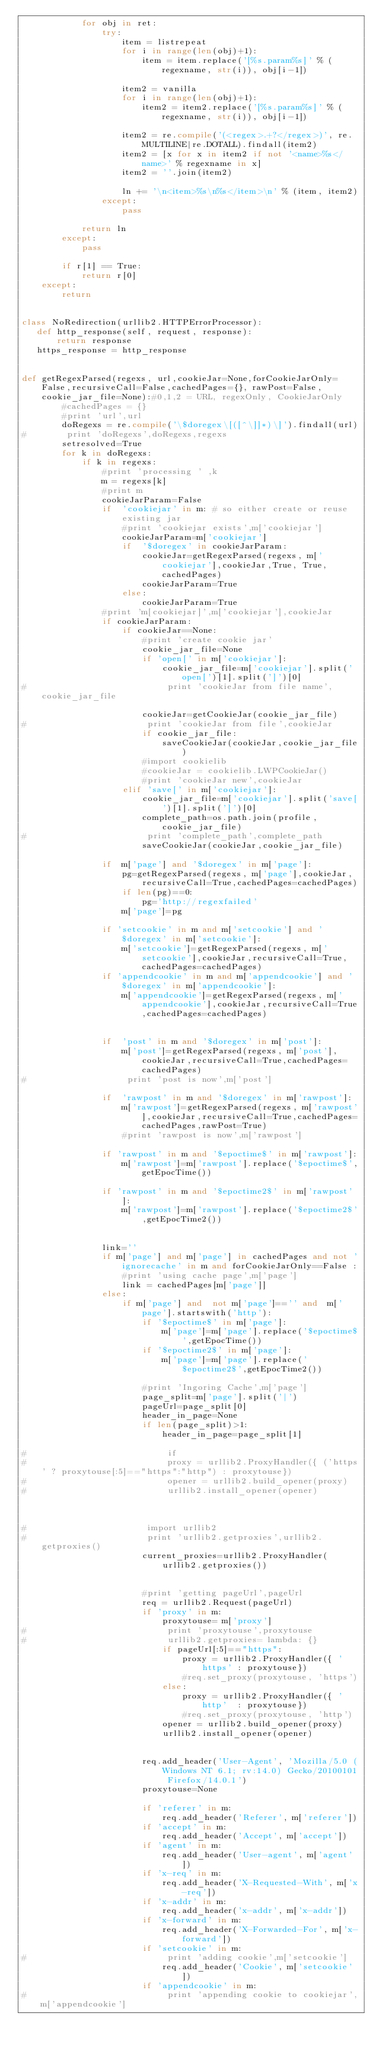<code> <loc_0><loc_0><loc_500><loc_500><_Python_>            for obj in ret:
                try:
                    item = listrepeat
                    for i in range(len(obj)+1):
                        item = item.replace('[%s.param%s]' % (regexname, str(i)), obj[i-1])

                    item2 = vanilla
                    for i in range(len(obj)+1):
                        item2 = item2.replace('[%s.param%s]' % (regexname, str(i)), obj[i-1])

                    item2 = re.compile('(<regex>.+?</regex>)', re.MULTILINE|re.DOTALL).findall(item2)
                    item2 = [x for x in item2 if not '<name>%s</name>' % regexname in x]
                    item2 = ''.join(item2)

                    ln += '\n<item>%s\n%s</item>\n' % (item, item2)
                except:
                    pass

            return ln
        except:
            pass

        if r[1] == True:
            return r[0]
    except:
        return


class NoRedirection(urllib2.HTTPErrorProcessor):
   def http_response(self, request, response):
       return response
   https_response = http_response


def getRegexParsed(regexs, url,cookieJar=None,forCookieJarOnly=False,recursiveCall=False,cachedPages={}, rawPost=False, cookie_jar_file=None):#0,1,2 = URL, regexOnly, CookieJarOnly
        #cachedPages = {}
        #print 'url',url
        doRegexs = re.compile('\$doregex\[([^\]]*)\]').findall(url)
#        print 'doRegexs',doRegexs,regexs
        setresolved=True
        for k in doRegexs:
            if k in regexs:
                #print 'processing ' ,k
                m = regexs[k]
                #print m
                cookieJarParam=False
                if  'cookiejar' in m: # so either create or reuse existing jar
                    #print 'cookiejar exists',m['cookiejar']
                    cookieJarParam=m['cookiejar']
                    if  '$doregex' in cookieJarParam:
                        cookieJar=getRegexParsed(regexs, m['cookiejar'],cookieJar,True, True,cachedPages)
                        cookieJarParam=True
                    else:
                        cookieJarParam=True
                #print 'm[cookiejar]',m['cookiejar'],cookieJar
                if cookieJarParam:
                    if cookieJar==None:
                        #print 'create cookie jar'
                        cookie_jar_file=None
                        if 'open[' in m['cookiejar']:
                            cookie_jar_file=m['cookiejar'].split('open[')[1].split(']')[0]
#                            print 'cookieJar from file name',cookie_jar_file

                        cookieJar=getCookieJar(cookie_jar_file)
#                        print 'cookieJar from file',cookieJar
                        if cookie_jar_file:
                            saveCookieJar(cookieJar,cookie_jar_file)
                        #import cookielib
                        #cookieJar = cookielib.LWPCookieJar()
                        #print 'cookieJar new',cookieJar
                    elif 'save[' in m['cookiejar']:
                        cookie_jar_file=m['cookiejar'].split('save[')[1].split(']')[0]
                        complete_path=os.path.join(profile,cookie_jar_file)
#                        print 'complete_path',complete_path
                        saveCookieJar(cookieJar,cookie_jar_file)

                if  m['page'] and '$doregex' in m['page']:
                    pg=getRegexParsed(regexs, m['page'],cookieJar,recursiveCall=True,cachedPages=cachedPages)
                    if len(pg)==0:
                        pg='http://regexfailed'
                    m['page']=pg

                if 'setcookie' in m and m['setcookie'] and '$doregex' in m['setcookie']:
                    m['setcookie']=getRegexParsed(regexs, m['setcookie'],cookieJar,recursiveCall=True,cachedPages=cachedPages)
                if 'appendcookie' in m and m['appendcookie'] and '$doregex' in m['appendcookie']:
                    m['appendcookie']=getRegexParsed(regexs, m['appendcookie'],cookieJar,recursiveCall=True,cachedPages=cachedPages)


                if  'post' in m and '$doregex' in m['post']:
                    m['post']=getRegexParsed(regexs, m['post'],cookieJar,recursiveCall=True,cachedPages=cachedPages)
#                    print 'post is now',m['post']

                if  'rawpost' in m and '$doregex' in m['rawpost']:
                    m['rawpost']=getRegexParsed(regexs, m['rawpost'],cookieJar,recursiveCall=True,cachedPages=cachedPages,rawPost=True)
                    #print 'rawpost is now',m['rawpost']

                if 'rawpost' in m and '$epoctime$' in m['rawpost']:
                    m['rawpost']=m['rawpost'].replace('$epoctime$',getEpocTime())

                if 'rawpost' in m and '$epoctime2$' in m['rawpost']:
                    m['rawpost']=m['rawpost'].replace('$epoctime2$',getEpocTime2())


                link=''
                if m['page'] and m['page'] in cachedPages and not 'ignorecache' in m and forCookieJarOnly==False :
                    #print 'using cache page',m['page']
                    link = cachedPages[m['page']]
                else:
                    if m['page'] and  not m['page']=='' and  m['page'].startswith('http'):
                        if '$epoctime$' in m['page']:
                            m['page']=m['page'].replace('$epoctime$',getEpocTime())
                        if '$epoctime2$' in m['page']:
                            m['page']=m['page'].replace('$epoctime2$',getEpocTime2())

                        #print 'Ingoring Cache',m['page']
                        page_split=m['page'].split('|')
                        pageUrl=page_split[0]
                        header_in_page=None
                        if len(page_split)>1:
                            header_in_page=page_split[1]

#                            if 
#                            proxy = urllib2.ProxyHandler({ ('https' ? proxytouse[:5]=="https":"http") : proxytouse})
#                            opener = urllib2.build_opener(proxy)
#                            urllib2.install_opener(opener)

                            
                        
#                        import urllib2
#                        print 'urllib2.getproxies',urllib2.getproxies()
                        current_proxies=urllib2.ProxyHandler(urllib2.getproxies())
        
        
                        #print 'getting pageUrl',pageUrl
                        req = urllib2.Request(pageUrl)
                        if 'proxy' in m:
                            proxytouse= m['proxy']
#                            print 'proxytouse',proxytouse
#                            urllib2.getproxies= lambda: {}
                            if pageUrl[:5]=="https":
                                proxy = urllib2.ProxyHandler({ 'https' : proxytouse})
                                #req.set_proxy(proxytouse, 'https')
                            else:
                                proxy = urllib2.ProxyHandler({ 'http'  : proxytouse})
                                #req.set_proxy(proxytouse, 'http')
                            opener = urllib2.build_opener(proxy)
                            urllib2.install_opener(opener)
                            
                        
                        req.add_header('User-Agent', 'Mozilla/5.0 (Windows NT 6.1; rv:14.0) Gecko/20100101 Firefox/14.0.1')
                        proxytouse=None

                        if 'referer' in m:
                            req.add_header('Referer', m['referer'])
                        if 'accept' in m:
                            req.add_header('Accept', m['accept'])
                        if 'agent' in m:
                            req.add_header('User-agent', m['agent'])
                        if 'x-req' in m:
                            req.add_header('X-Requested-With', m['x-req'])
                        if 'x-addr' in m:
                            req.add_header('x-addr', m['x-addr'])
                        if 'x-forward' in m:
                            req.add_header('X-Forwarded-For', m['x-forward'])
                        if 'setcookie' in m:
#                            print 'adding cookie',m['setcookie']
                            req.add_header('Cookie', m['setcookie'])
                        if 'appendcookie' in m:
#                            print 'appending cookie to cookiejar',m['appendcookie']</code> 